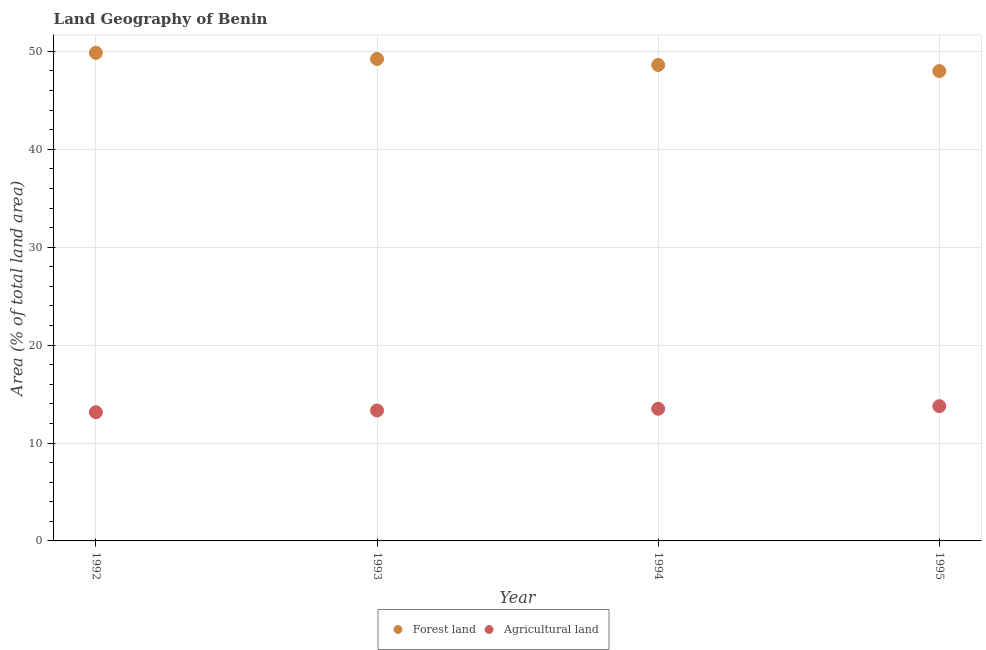How many different coloured dotlines are there?
Keep it short and to the point. 2. What is the percentage of land area under agriculture in 1994?
Ensure brevity in your answer.  13.5. Across all years, what is the maximum percentage of land area under agriculture?
Give a very brief answer. 13.76. Across all years, what is the minimum percentage of land area under agriculture?
Your response must be concise. 13.14. In which year was the percentage of land area under agriculture maximum?
Make the answer very short. 1995. What is the total percentage of land area under agriculture in the graph?
Give a very brief answer. 53.72. What is the difference between the percentage of land area under agriculture in 1992 and that in 1995?
Your answer should be compact. -0.62. What is the difference between the percentage of land area under forests in 1994 and the percentage of land area under agriculture in 1993?
Offer a terse response. 35.29. What is the average percentage of land area under forests per year?
Provide a short and direct response. 48.92. In the year 1995, what is the difference between the percentage of land area under agriculture and percentage of land area under forests?
Provide a succinct answer. -34.22. In how many years, is the percentage of land area under agriculture greater than 18 %?
Provide a succinct answer. 0. What is the ratio of the percentage of land area under agriculture in 1992 to that in 1995?
Ensure brevity in your answer.  0.95. Is the difference between the percentage of land area under forests in 1993 and 1995 greater than the difference between the percentage of land area under agriculture in 1993 and 1995?
Offer a terse response. Yes. What is the difference between the highest and the second highest percentage of land area under forests?
Your answer should be very brief. 0.62. What is the difference between the highest and the lowest percentage of land area under forests?
Your response must be concise. 1.86. Does the percentage of land area under agriculture monotonically increase over the years?
Your answer should be very brief. Yes. Is the percentage of land area under agriculture strictly greater than the percentage of land area under forests over the years?
Ensure brevity in your answer.  No. How many dotlines are there?
Your answer should be compact. 2. What is the difference between two consecutive major ticks on the Y-axis?
Make the answer very short. 10. Does the graph contain any zero values?
Your response must be concise. No. Does the graph contain grids?
Ensure brevity in your answer.  Yes. Where does the legend appear in the graph?
Provide a short and direct response. Bottom center. How are the legend labels stacked?
Ensure brevity in your answer.  Horizontal. What is the title of the graph?
Provide a short and direct response. Land Geography of Benin. What is the label or title of the X-axis?
Provide a succinct answer. Year. What is the label or title of the Y-axis?
Ensure brevity in your answer.  Area (% of total land area). What is the Area (% of total land area) in Forest land in 1992?
Offer a terse response. 49.85. What is the Area (% of total land area) of Agricultural land in 1992?
Give a very brief answer. 13.14. What is the Area (% of total land area) in Forest land in 1993?
Your answer should be very brief. 49.23. What is the Area (% of total land area) in Agricultural land in 1993?
Provide a short and direct response. 13.32. What is the Area (% of total land area) of Forest land in 1994?
Offer a very short reply. 48.61. What is the Area (% of total land area) in Agricultural land in 1994?
Provide a succinct answer. 13.5. What is the Area (% of total land area) of Forest land in 1995?
Your answer should be compact. 47.99. What is the Area (% of total land area) of Agricultural land in 1995?
Your answer should be compact. 13.76. Across all years, what is the maximum Area (% of total land area) in Forest land?
Offer a very short reply. 49.85. Across all years, what is the maximum Area (% of total land area) in Agricultural land?
Provide a short and direct response. 13.76. Across all years, what is the minimum Area (% of total land area) of Forest land?
Keep it short and to the point. 47.99. Across all years, what is the minimum Area (% of total land area) in Agricultural land?
Provide a succinct answer. 13.14. What is the total Area (% of total land area) of Forest land in the graph?
Provide a short and direct response. 195.67. What is the total Area (% of total land area) of Agricultural land in the graph?
Provide a succinct answer. 53.72. What is the difference between the Area (% of total land area) of Forest land in 1992 and that in 1993?
Your answer should be compact. 0.62. What is the difference between the Area (% of total land area) of Agricultural land in 1992 and that in 1993?
Make the answer very short. -0.18. What is the difference between the Area (% of total land area) in Forest land in 1992 and that in 1994?
Your answer should be compact. 1.24. What is the difference between the Area (% of total land area) of Agricultural land in 1992 and that in 1994?
Offer a very short reply. -0.35. What is the difference between the Area (% of total land area) in Forest land in 1992 and that in 1995?
Offer a very short reply. 1.86. What is the difference between the Area (% of total land area) in Agricultural land in 1992 and that in 1995?
Offer a very short reply. -0.62. What is the difference between the Area (% of total land area) in Forest land in 1993 and that in 1994?
Make the answer very short. 0.62. What is the difference between the Area (% of total land area) in Agricultural land in 1993 and that in 1994?
Your answer should be very brief. -0.18. What is the difference between the Area (% of total land area) in Forest land in 1993 and that in 1995?
Your answer should be compact. 1.24. What is the difference between the Area (% of total land area) of Agricultural land in 1993 and that in 1995?
Ensure brevity in your answer.  -0.44. What is the difference between the Area (% of total land area) of Forest land in 1994 and that in 1995?
Offer a very short reply. 0.62. What is the difference between the Area (% of total land area) of Agricultural land in 1994 and that in 1995?
Your answer should be compact. -0.27. What is the difference between the Area (% of total land area) of Forest land in 1992 and the Area (% of total land area) of Agricultural land in 1993?
Make the answer very short. 36.53. What is the difference between the Area (% of total land area) in Forest land in 1992 and the Area (% of total land area) in Agricultural land in 1994?
Offer a very short reply. 36.35. What is the difference between the Area (% of total land area) in Forest land in 1992 and the Area (% of total land area) in Agricultural land in 1995?
Offer a very short reply. 36.09. What is the difference between the Area (% of total land area) of Forest land in 1993 and the Area (% of total land area) of Agricultural land in 1994?
Your answer should be very brief. 35.73. What is the difference between the Area (% of total land area) of Forest land in 1993 and the Area (% of total land area) of Agricultural land in 1995?
Offer a very short reply. 35.46. What is the difference between the Area (% of total land area) of Forest land in 1994 and the Area (% of total land area) of Agricultural land in 1995?
Make the answer very short. 34.84. What is the average Area (% of total land area) of Forest land per year?
Ensure brevity in your answer.  48.92. What is the average Area (% of total land area) of Agricultural land per year?
Provide a short and direct response. 13.43. In the year 1992, what is the difference between the Area (% of total land area) in Forest land and Area (% of total land area) in Agricultural land?
Provide a succinct answer. 36.71. In the year 1993, what is the difference between the Area (% of total land area) in Forest land and Area (% of total land area) in Agricultural land?
Provide a short and direct response. 35.91. In the year 1994, what is the difference between the Area (% of total land area) of Forest land and Area (% of total land area) of Agricultural land?
Your answer should be very brief. 35.11. In the year 1995, what is the difference between the Area (% of total land area) in Forest land and Area (% of total land area) in Agricultural land?
Offer a terse response. 34.22. What is the ratio of the Area (% of total land area) in Forest land in 1992 to that in 1993?
Keep it short and to the point. 1.01. What is the ratio of the Area (% of total land area) of Agricultural land in 1992 to that in 1993?
Your answer should be compact. 0.99. What is the ratio of the Area (% of total land area) in Forest land in 1992 to that in 1994?
Make the answer very short. 1.03. What is the ratio of the Area (% of total land area) of Agricultural land in 1992 to that in 1994?
Ensure brevity in your answer.  0.97. What is the ratio of the Area (% of total land area) in Forest land in 1992 to that in 1995?
Make the answer very short. 1.04. What is the ratio of the Area (% of total land area) of Agricultural land in 1992 to that in 1995?
Provide a short and direct response. 0.95. What is the ratio of the Area (% of total land area) of Forest land in 1993 to that in 1994?
Keep it short and to the point. 1.01. What is the ratio of the Area (% of total land area) in Agricultural land in 1993 to that in 1994?
Keep it short and to the point. 0.99. What is the ratio of the Area (% of total land area) of Forest land in 1993 to that in 1995?
Provide a succinct answer. 1.03. What is the ratio of the Area (% of total land area) of Agricultural land in 1993 to that in 1995?
Keep it short and to the point. 0.97. What is the ratio of the Area (% of total land area) in Forest land in 1994 to that in 1995?
Make the answer very short. 1.01. What is the ratio of the Area (% of total land area) in Agricultural land in 1994 to that in 1995?
Keep it short and to the point. 0.98. What is the difference between the highest and the second highest Area (% of total land area) of Forest land?
Provide a succinct answer. 0.62. What is the difference between the highest and the second highest Area (% of total land area) of Agricultural land?
Make the answer very short. 0.27. What is the difference between the highest and the lowest Area (% of total land area) in Forest land?
Your answer should be compact. 1.86. What is the difference between the highest and the lowest Area (% of total land area) of Agricultural land?
Offer a very short reply. 0.62. 